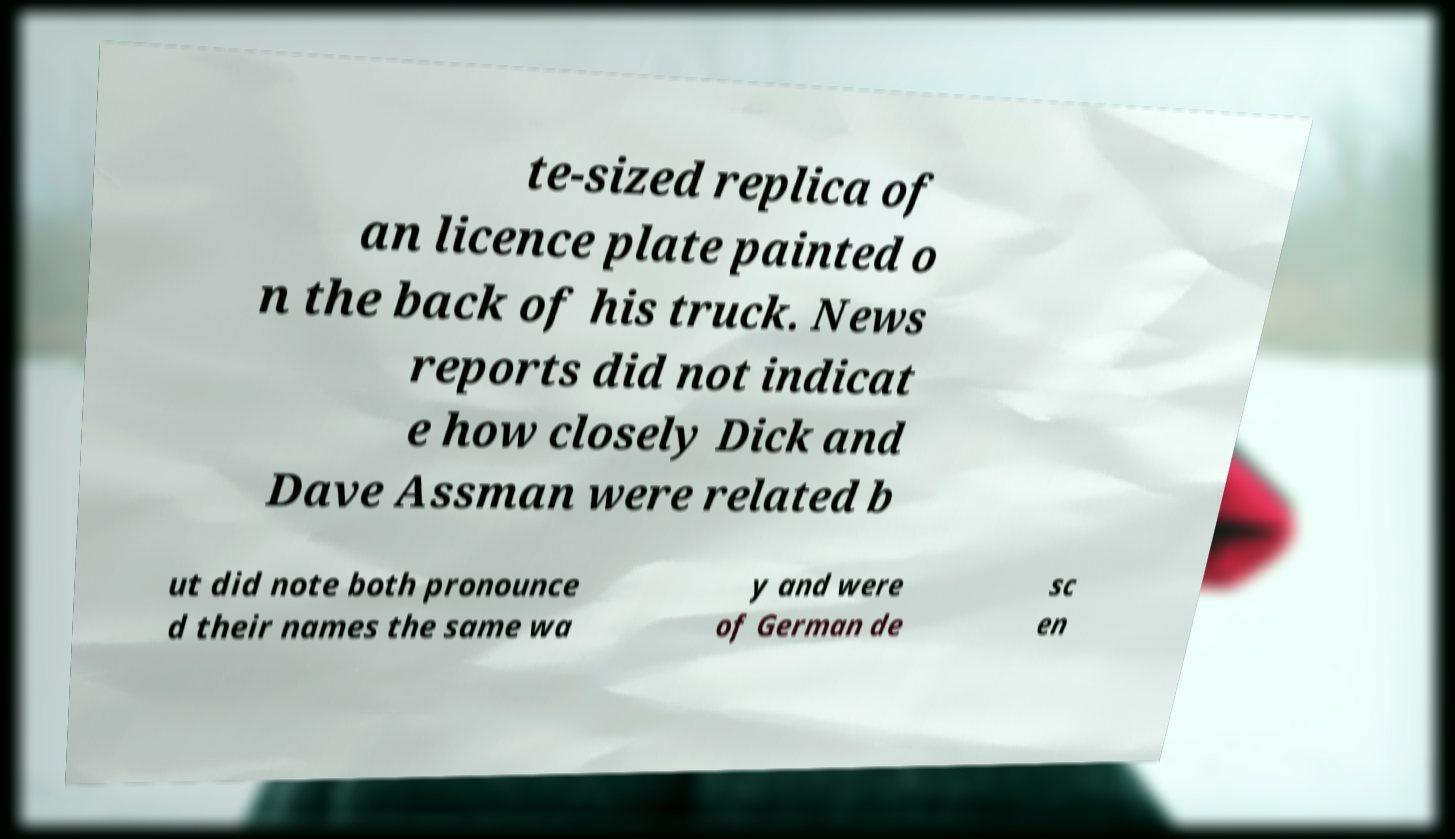Can you read and provide the text displayed in the image?This photo seems to have some interesting text. Can you extract and type it out for me? te-sized replica of an licence plate painted o n the back of his truck. News reports did not indicat e how closely Dick and Dave Assman were related b ut did note both pronounce d their names the same wa y and were of German de sc en 